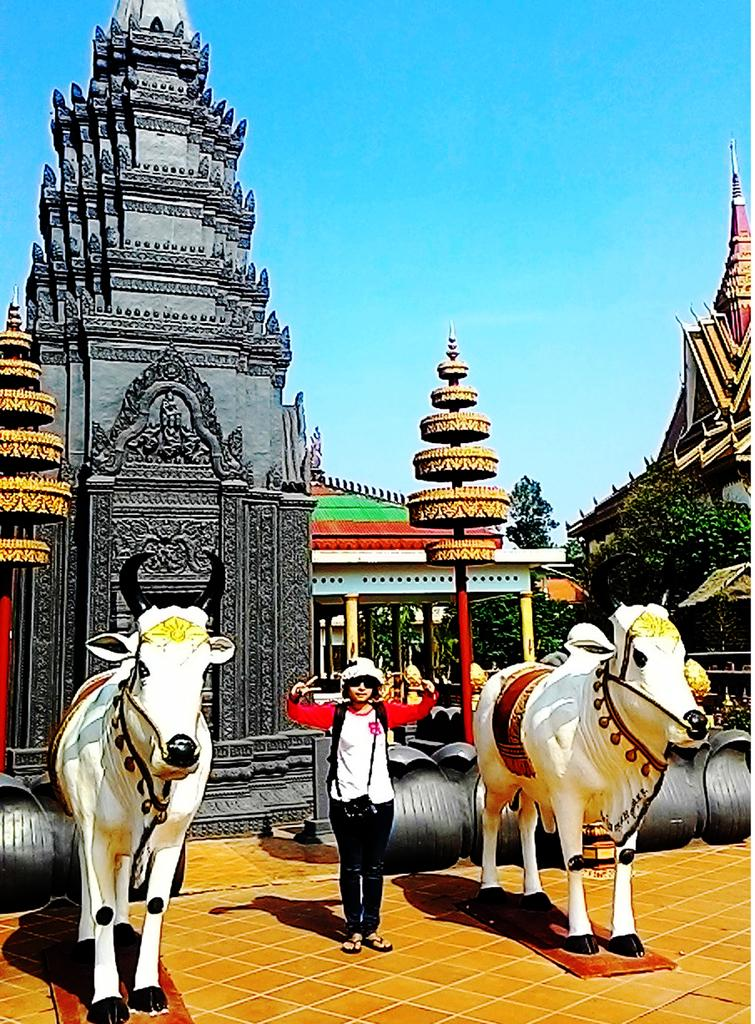Who or what is the main subject in the image? There is a person in the image. What other subjects can be seen in the image? There are statues of animals and ancient architecture present in the image. What type of natural elements are in the image? There are trees in the image. What else can be seen in the image that is not specified? There are unspecified objects in the image. What is visible in the background of the image? The sky is visible in the background of the image. What arithmetic problem is the person solving in the image? There is no indication in the image that the person is solving an arithmetic problem. 